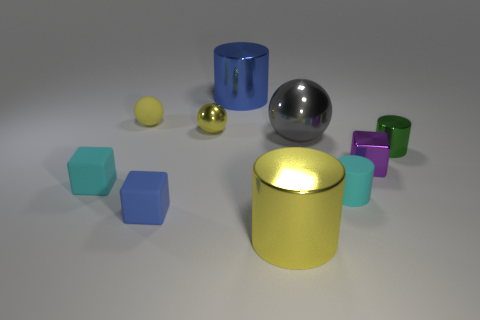Subtract all blocks. How many objects are left? 7 Add 5 rubber objects. How many rubber objects exist? 9 Subtract 0 purple cylinders. How many objects are left? 10 Subtract all brown balls. Subtract all purple shiny blocks. How many objects are left? 9 Add 3 cyan rubber blocks. How many cyan rubber blocks are left? 4 